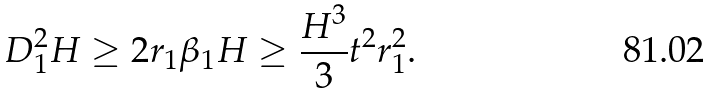<formula> <loc_0><loc_0><loc_500><loc_500>D _ { 1 } ^ { 2 } H \geq 2 r _ { 1 } \beta _ { 1 } H \geq \frac { H ^ { 3 } } { 3 } t ^ { 2 } r _ { 1 } ^ { 2 } .</formula> 